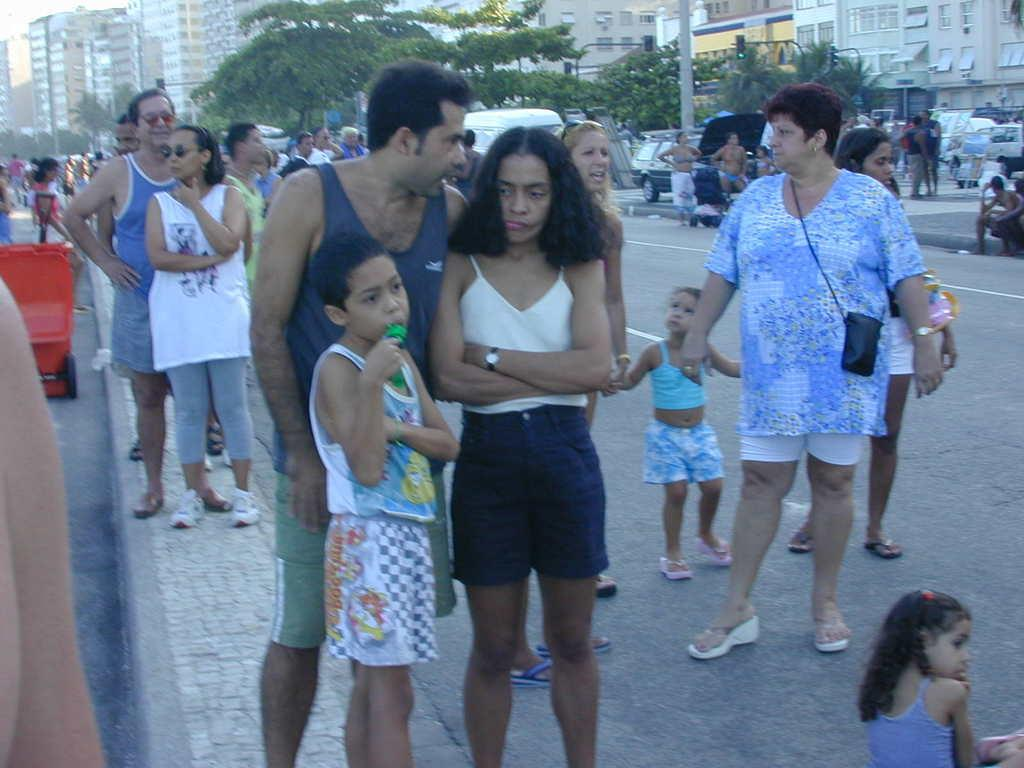What are the people in the image doing? Some people are standing, while others are seated in the image. What structures can be seen in the image? There are buildings visible in the image. What type of vegetation is present in the image? There are trees in the image. What vehicles can be seen in the image? There are parked cars in the image. What object is being used by the woman in the image? A woman is holding an umbrella in the image. What type of whistle can be heard in the image? There is no whistle present in the image, and therefore no sound can be heard. What is on the wrist of the person in the image? The image does not show any person wearing a wrist accessory or object. 